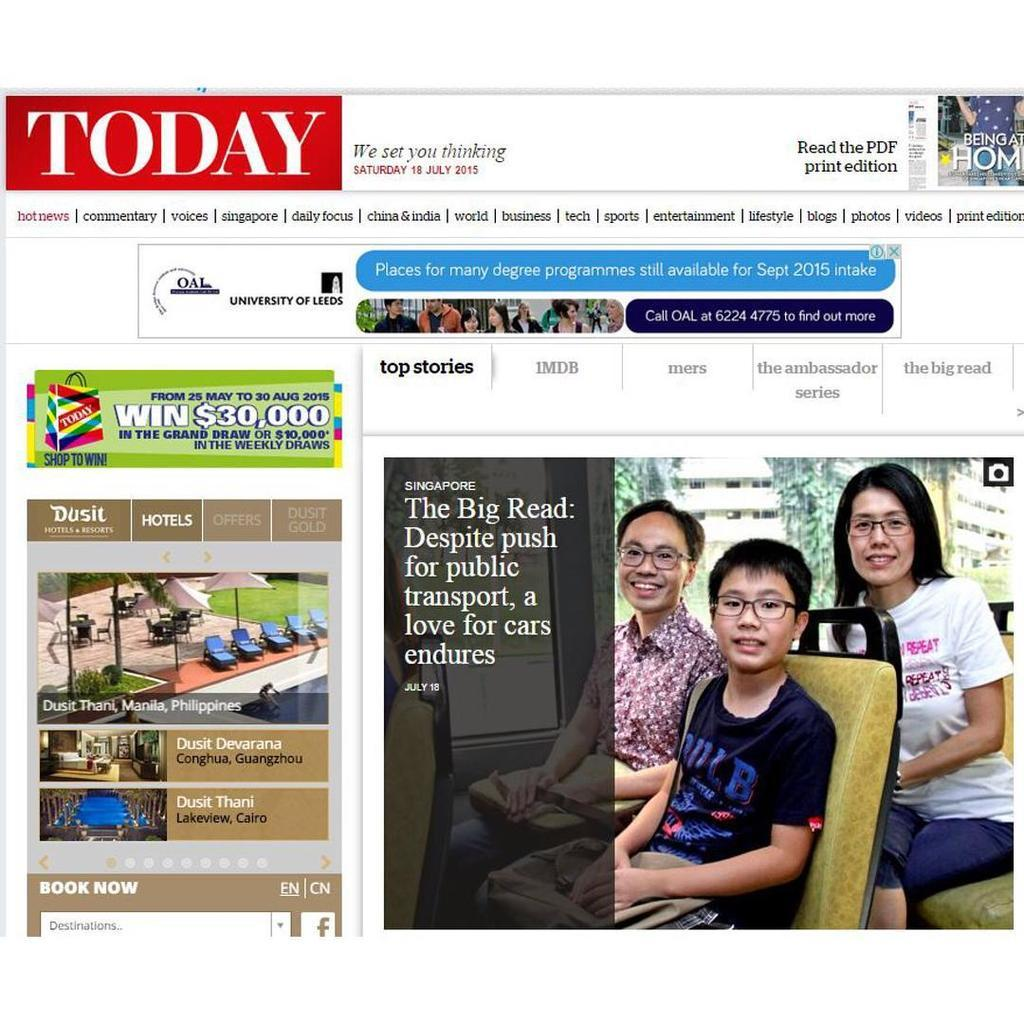<image>
Write a terse but informative summary of the picture. A web page for Today news that has some ads and a feature story and picture about public transportation. 